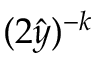<formula> <loc_0><loc_0><loc_500><loc_500>( 2 \hat { y } ) ^ { - k }</formula> 